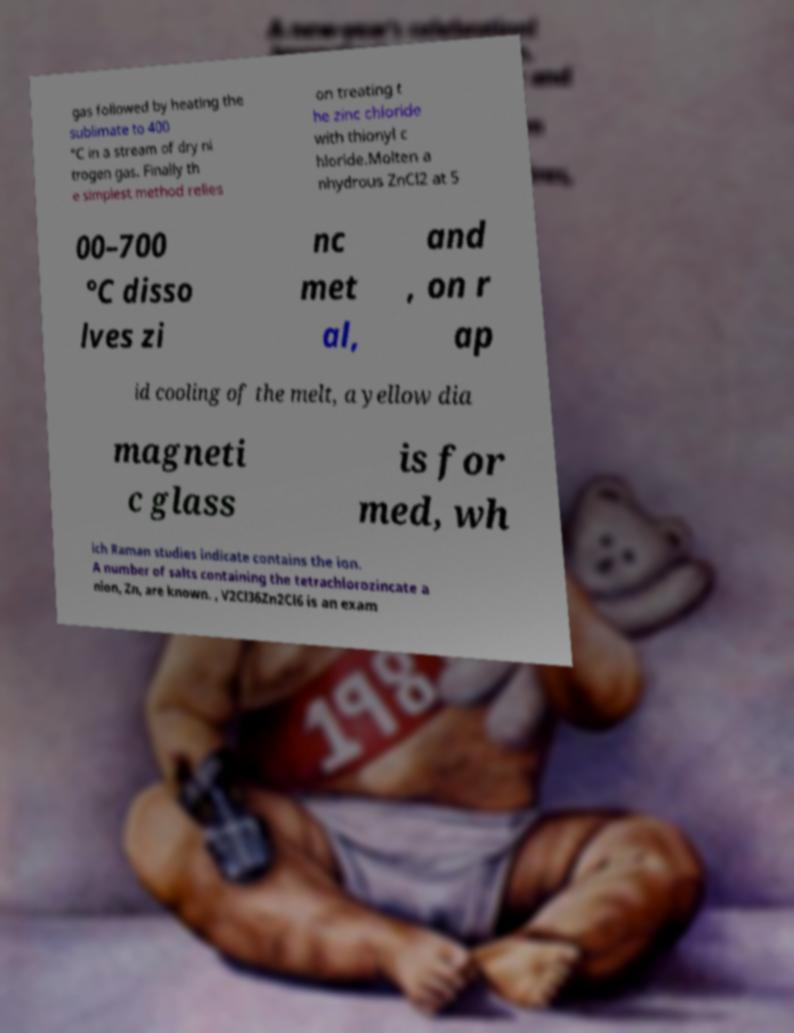Could you assist in decoding the text presented in this image and type it out clearly? gas followed by heating the sublimate to 400 °C in a stream of dry ni trogen gas. Finally th e simplest method relies on treating t he zinc chloride with thionyl c hloride.Molten a nhydrous ZnCl2 at 5 00–700 °C disso lves zi nc met al, and , on r ap id cooling of the melt, a yellow dia magneti c glass is for med, wh ich Raman studies indicate contains the ion. A number of salts containing the tetrachlorozincate a nion, Zn, are known. , V2Cl36Zn2Cl6 is an exam 